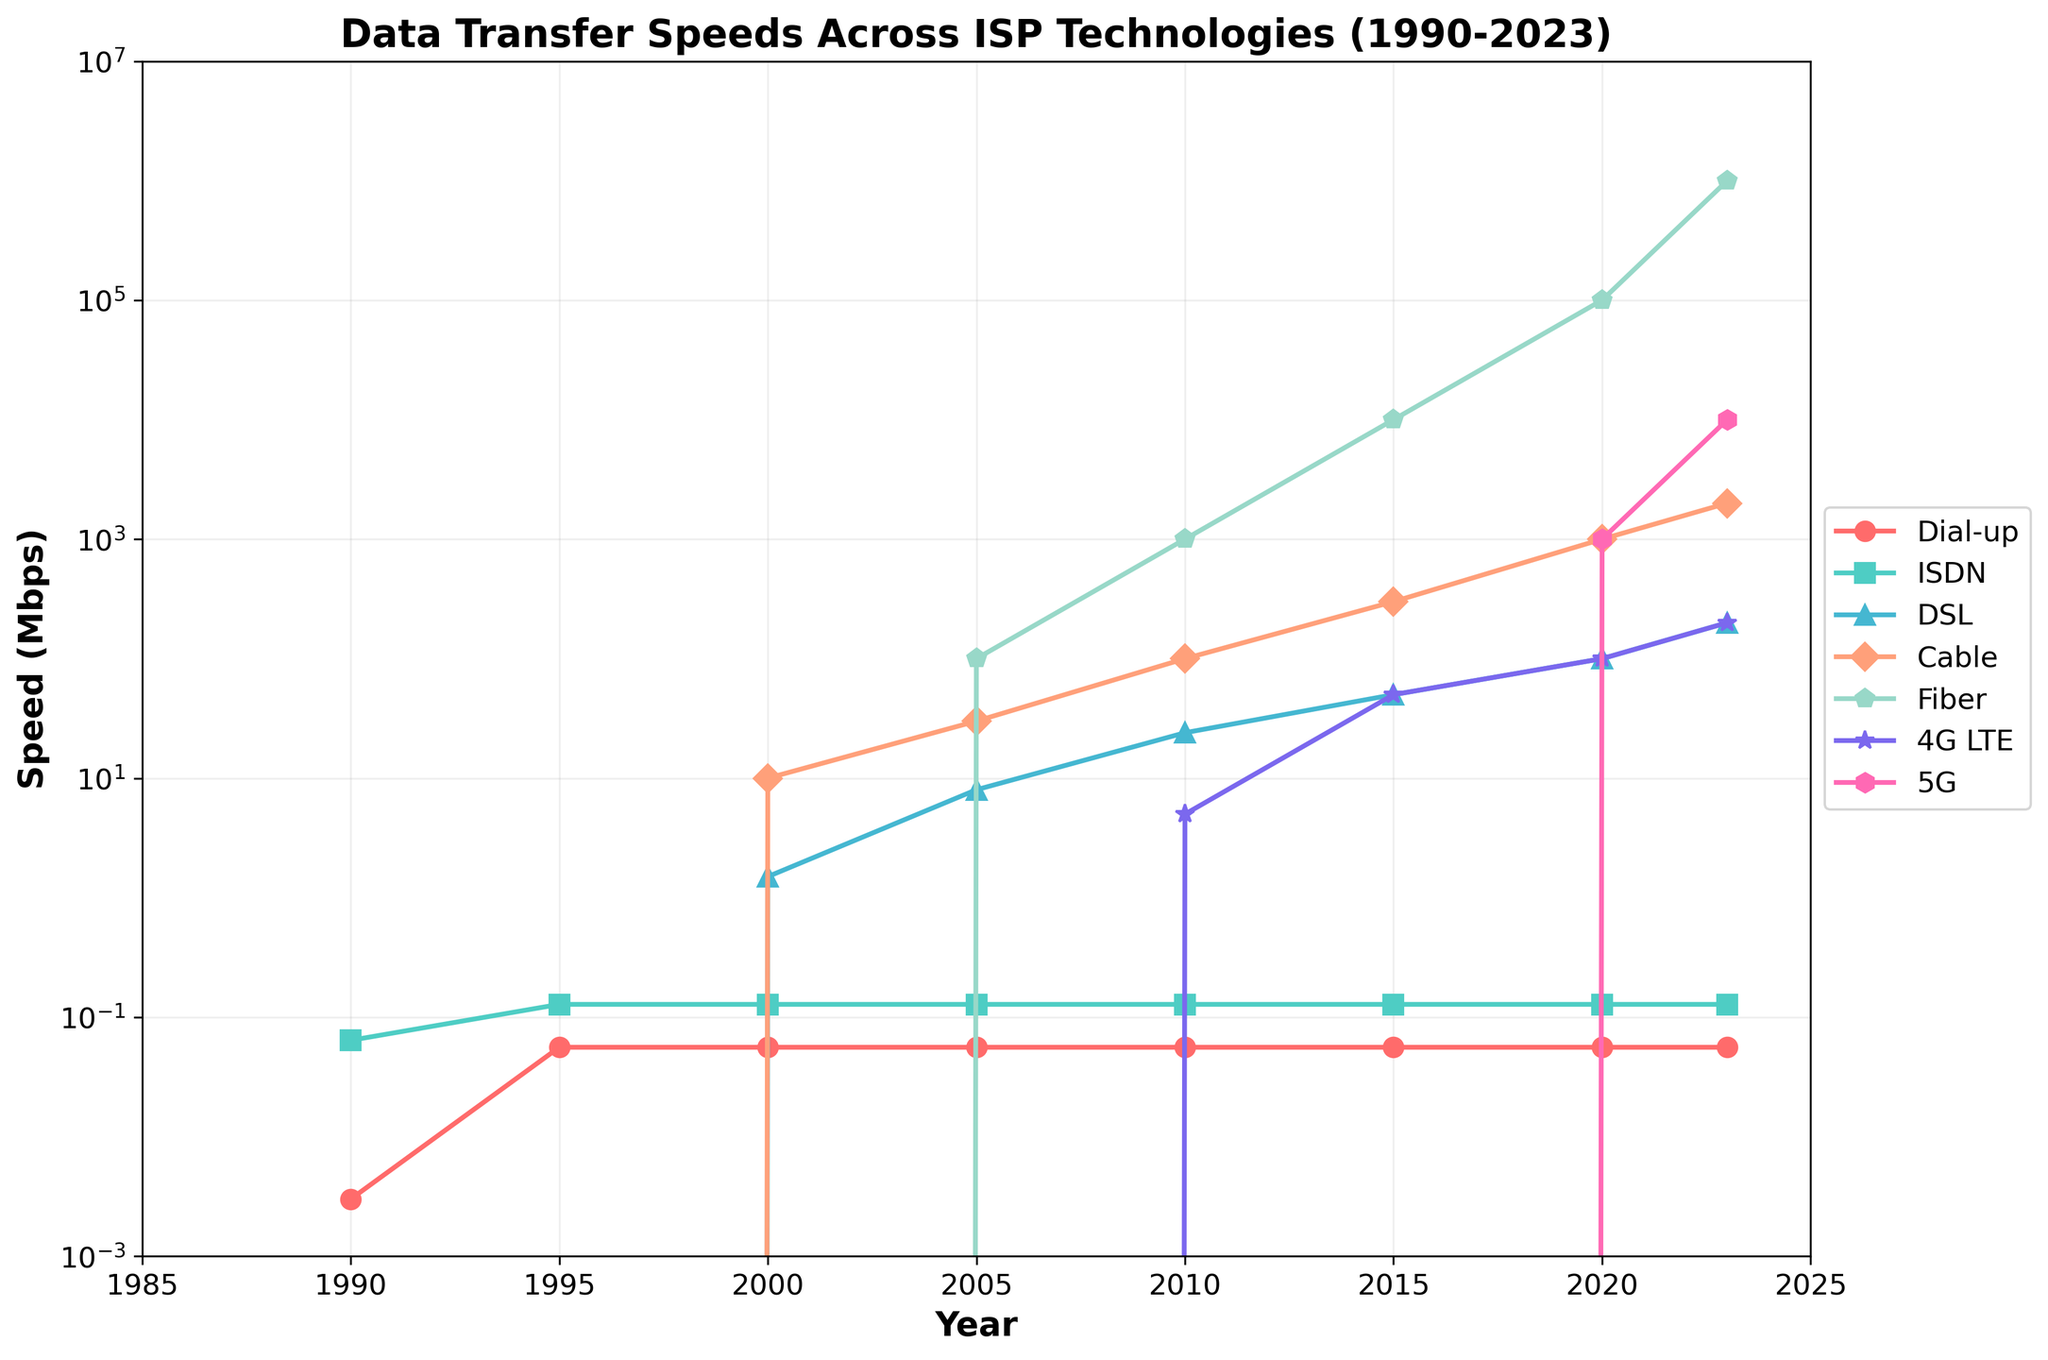Which ISP technology had the highest data transfer speed in 2023? Look at the year 2023 on the x-axis and find the highest point among all the technologies. Fiber has a data transfer speed leading up to 1000000 Mbps.
Answer: Fiber How much higher are the data transfer speeds of 5G in 2023 compared to 4G LTE in 2015? Find the data for 5G in 2023, which is 10000 Mbps, and 4G LTE in 2015, which is 50 Mbps. Calculate the difference: 10000 - 50 = 9950 Mbps.
Answer: 9950 Mbps What is the average data transfer speed of DSL in the years 2000, 2010, and 2020? The speeds for DSL are 1.5 Mbps (2000), 24 Mbps (2010), and 100 Mbps (2020). Calculate the average: (1.5 + 24 + 100) / 3 ≈ 41.83 Mbps.
Answer: 41.83 Mbps Which technology saw the biggest relative improvement in data transfer speed from 1990 to 2023? Compare the ratio of data transfer speeds in 2023 to 1990 for each technology. Fiber had the highest increase, going from 0 to 1000000 Mbps.
Answer: Fiber Between 1990 and 2023, how many times did the data transfer speed of Cable increase? Cable's data transfer speed in 1990 was 0 Mbps and in 2023 was 2000 Mbps. Technically, the increase from non-existence to 2000 Mbps can be substantial but a proper calculation isn't feasible as the initial value is zero.
Answer: N/A In which year did DSL's data transfer speed first surpass 10 Mbps? Track DSL’s data speed progression over the years. It first surpasses 10 Mbps in 2005 with a speed of 8 Mbps before reaching 24 Mbps in 2010.
Answer: 2010 What is the speed difference between ISDN and Fiber in the year 2005? ISDN had a speed of 0.128 Mbps in 2005 and Fiber had 100 Mbps. The difference is 100 - 0.128 ≈ 99.872 Mbps.
Answer: 99.872 Mbps What color represents the 5G technology in the plot? Identify the marker and color for the 5G technology from the legend. The color representing 5G is pink.
Answer: Pink Which technology had a consistent speed over the given time period? Examine the y-axis values for each technology across all years. Dial-up consistently stayed at around 0.056 Mbps.
Answer: Dial-up 